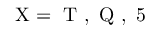<formula> <loc_0><loc_0><loc_500><loc_500>{ X = T , Q , 5 }</formula> 